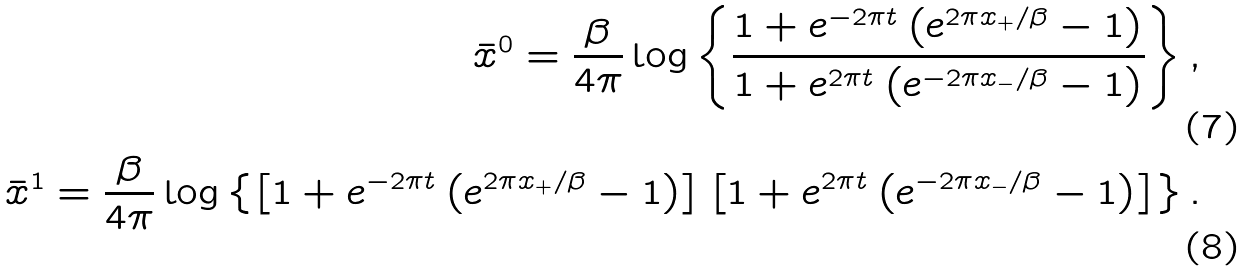<formula> <loc_0><loc_0><loc_500><loc_500>\bar { x } ^ { 0 } = \frac { \beta } { 4 \pi } \log \left \{ \frac { 1 + e ^ { - 2 \pi t } \left ( e ^ { 2 \pi x _ { + } / \beta } - 1 \right ) } { 1 + e ^ { 2 \pi t } \left ( e ^ { - 2 \pi x _ { - } / \beta } - 1 \right ) } \right \} , \\ \bar { x } ^ { 1 } = \frac { \beta } { 4 \pi } \log \left \{ \left [ 1 + e ^ { - 2 \pi t } \left ( e ^ { 2 \pi x _ { + } / \beta } - 1 \right ) \right ] \left [ 1 + e ^ { 2 \pi t } \left ( e ^ { - 2 \pi x _ { - } / \beta } - 1 \right ) \right ] \right \} .</formula> 